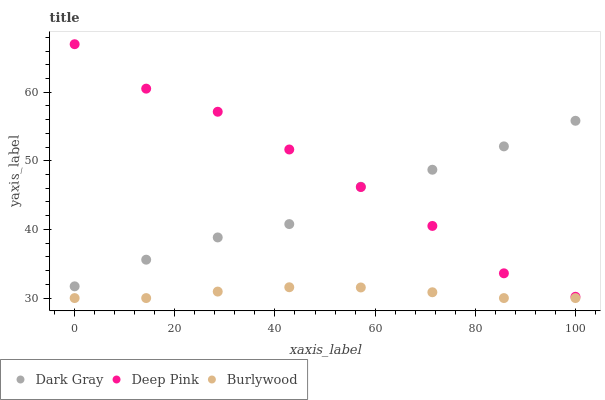Does Burlywood have the minimum area under the curve?
Answer yes or no. Yes. Does Deep Pink have the maximum area under the curve?
Answer yes or no. Yes. Does Deep Pink have the minimum area under the curve?
Answer yes or no. No. Does Burlywood have the maximum area under the curve?
Answer yes or no. No. Is Burlywood the smoothest?
Answer yes or no. Yes. Is Deep Pink the roughest?
Answer yes or no. Yes. Is Deep Pink the smoothest?
Answer yes or no. No. Is Burlywood the roughest?
Answer yes or no. No. Does Burlywood have the lowest value?
Answer yes or no. Yes. Does Deep Pink have the lowest value?
Answer yes or no. No. Does Deep Pink have the highest value?
Answer yes or no. Yes. Does Burlywood have the highest value?
Answer yes or no. No. Is Burlywood less than Dark Gray?
Answer yes or no. Yes. Is Deep Pink greater than Burlywood?
Answer yes or no. Yes. Does Deep Pink intersect Dark Gray?
Answer yes or no. Yes. Is Deep Pink less than Dark Gray?
Answer yes or no. No. Is Deep Pink greater than Dark Gray?
Answer yes or no. No. Does Burlywood intersect Dark Gray?
Answer yes or no. No. 